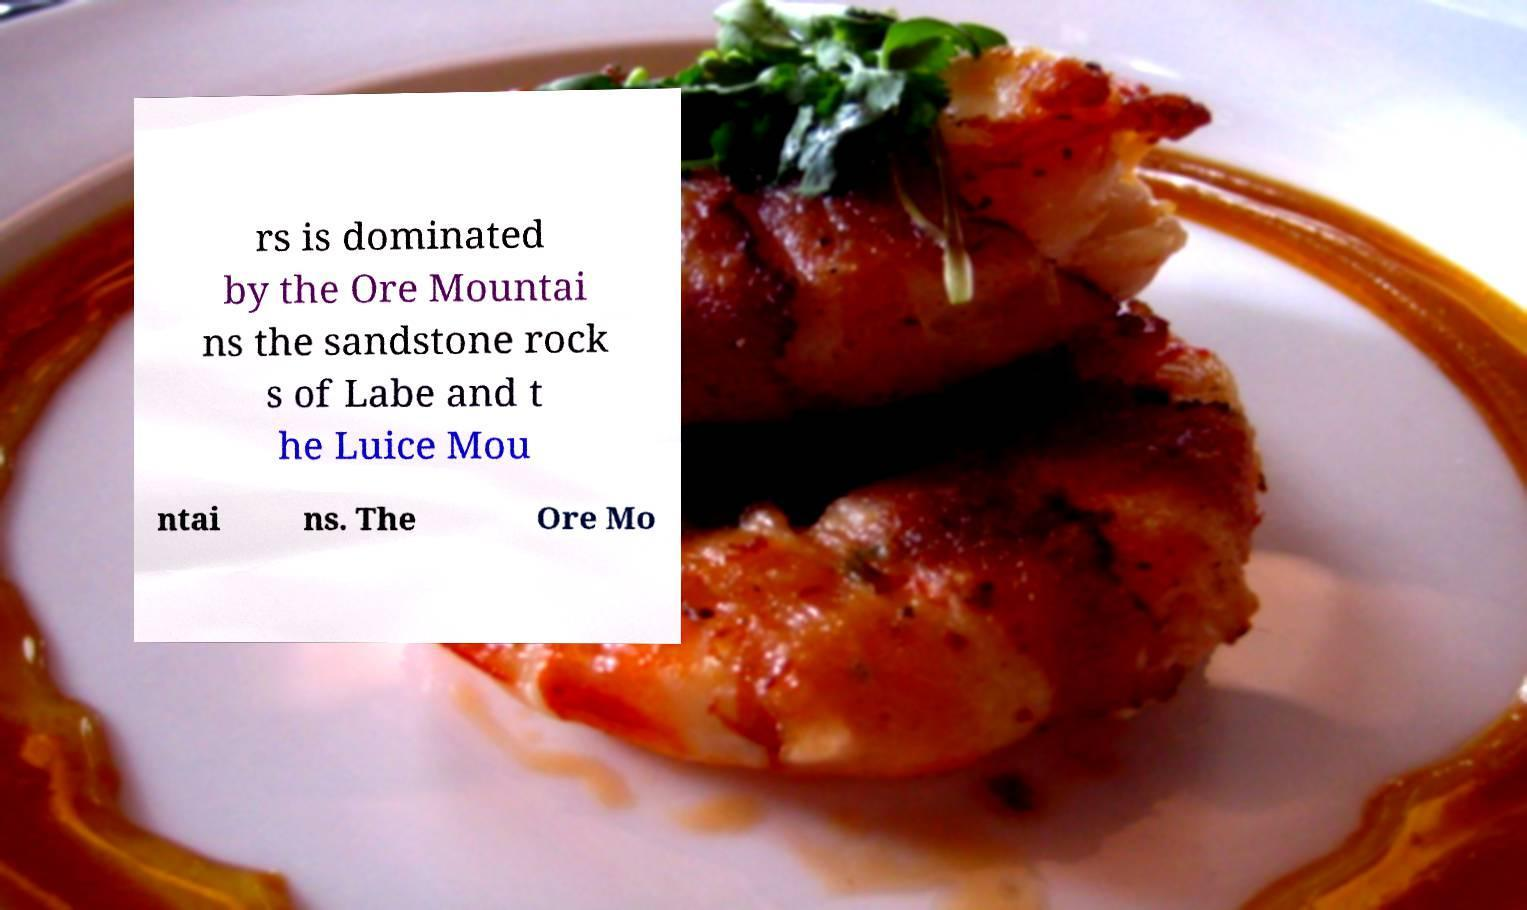Please identify and transcribe the text found in this image. rs is dominated by the Ore Mountai ns the sandstone rock s of Labe and t he Luice Mou ntai ns. The Ore Mo 